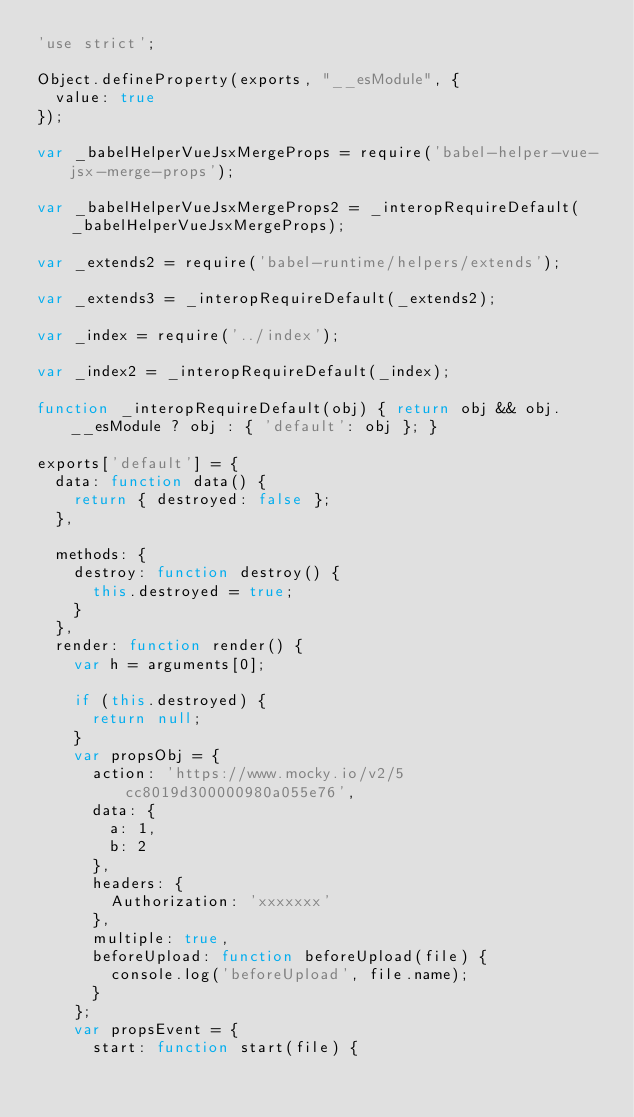Convert code to text. <code><loc_0><loc_0><loc_500><loc_500><_JavaScript_>'use strict';

Object.defineProperty(exports, "__esModule", {
  value: true
});

var _babelHelperVueJsxMergeProps = require('babel-helper-vue-jsx-merge-props');

var _babelHelperVueJsxMergeProps2 = _interopRequireDefault(_babelHelperVueJsxMergeProps);

var _extends2 = require('babel-runtime/helpers/extends');

var _extends3 = _interopRequireDefault(_extends2);

var _index = require('../index');

var _index2 = _interopRequireDefault(_index);

function _interopRequireDefault(obj) { return obj && obj.__esModule ? obj : { 'default': obj }; }

exports['default'] = {
  data: function data() {
    return { destroyed: false };
  },

  methods: {
    destroy: function destroy() {
      this.destroyed = true;
    }
  },
  render: function render() {
    var h = arguments[0];

    if (this.destroyed) {
      return null;
    }
    var propsObj = {
      action: 'https://www.mocky.io/v2/5cc8019d300000980a055e76',
      data: {
        a: 1,
        b: 2
      },
      headers: {
        Authorization: 'xxxxxxx'
      },
      multiple: true,
      beforeUpload: function beforeUpload(file) {
        console.log('beforeUpload', file.name);
      }
    };
    var propsEvent = {
      start: function start(file) {</code> 